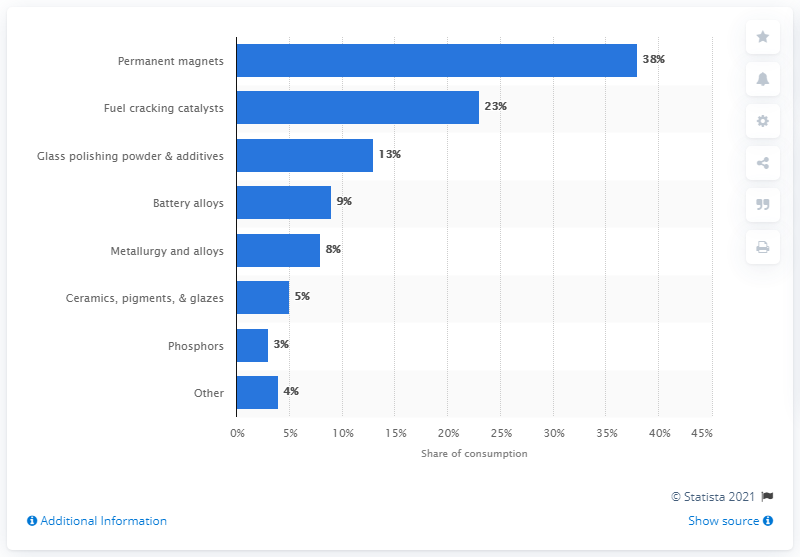Indicate a few pertinent items in this graphic. In 2019, permanent magnets accounted for approximately 38% of global rare earth element (REE) consumption. 